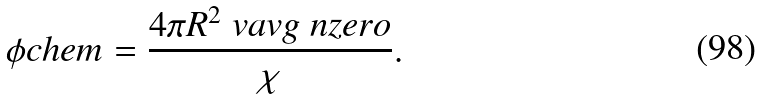Convert formula to latex. <formula><loc_0><loc_0><loc_500><loc_500>\phi c h e m = \frac { 4 \pi R ^ { 2 } \ v a v g \ n z e r o } { \chi } .</formula> 